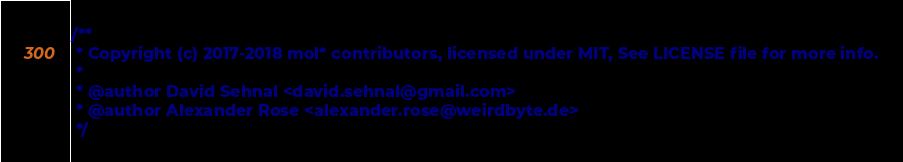<code> <loc_0><loc_0><loc_500><loc_500><_TypeScript_>/**
 * Copyright (c) 2017-2018 mol* contributors, licensed under MIT, See LICENSE file for more info.
 *
 * @author David Sehnal <david.sehnal@gmail.com>
 * @author Alexander Rose <alexander.rose@weirdbyte.de>
 */
</code> 